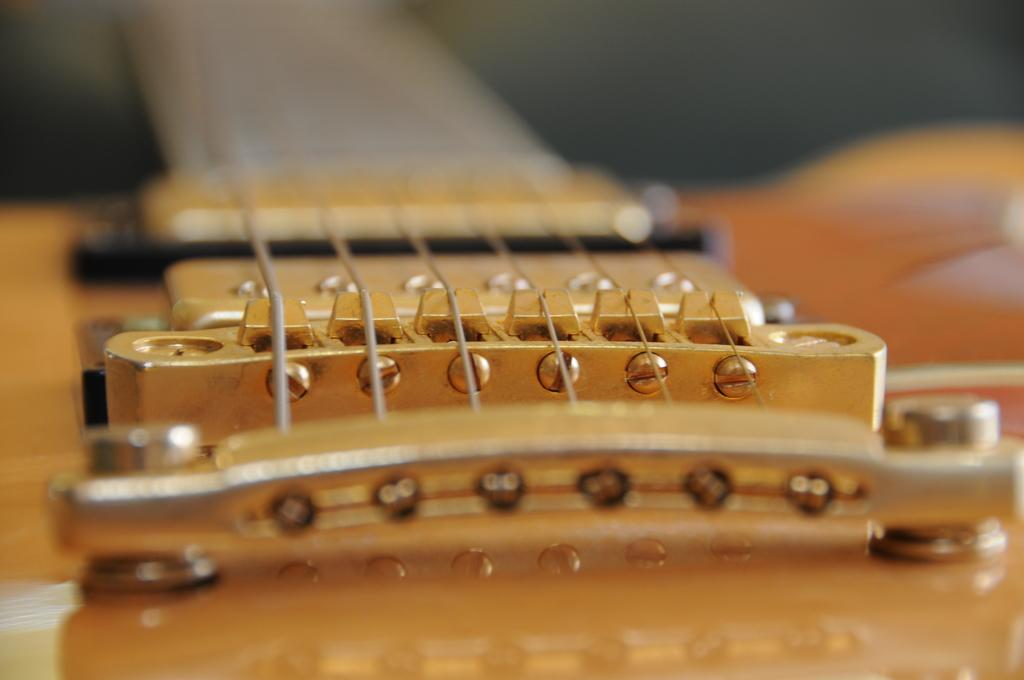What is the main subject of the image? The main subject of the image is guitar strings. Can you describe the guitar strings in the image? The guitar strings are located in the center of the image. What type of structure can be seen supporting the airplane in the image? There is no airplane or structure present in the image; it only features guitar strings. 